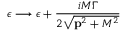<formula> <loc_0><loc_0><loc_500><loc_500>\epsilon \longrightarrow \epsilon + \frac { i M \Gamma } { 2 \sqrt { { p } ^ { 2 } + M ^ { 2 } } }</formula> 